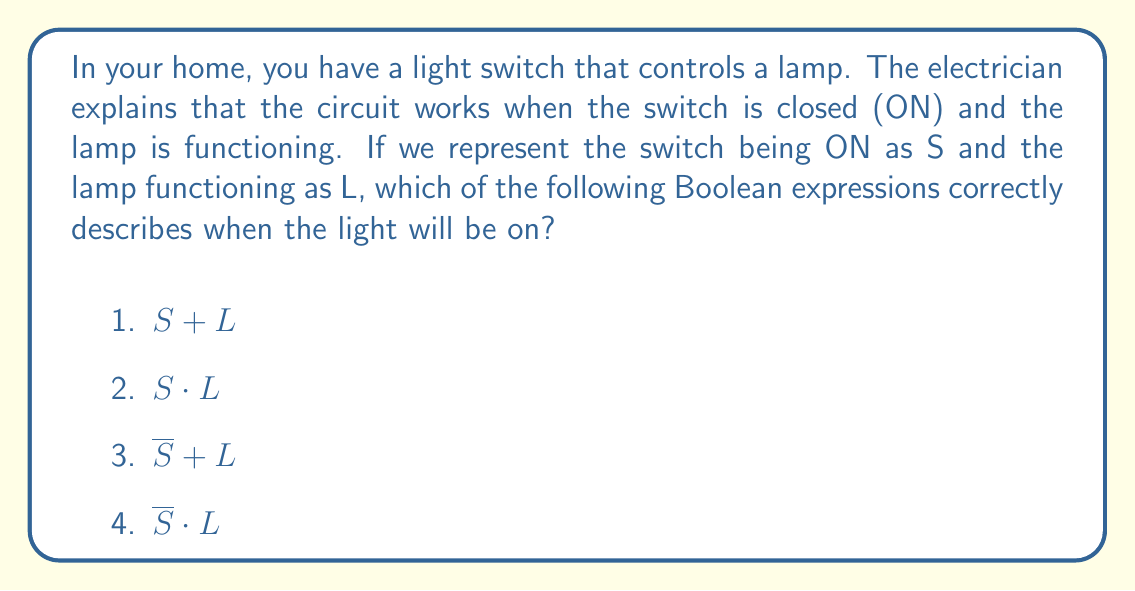Solve this math problem. Let's break this down step-by-step:

1) First, we need to understand what the symbols mean:
   - $S$ represents the switch being ON
   - $L$ represents the lamp functioning
   - The dot $\cdot$ means AND in Boolean logic
   - The plus $+$ means OR in Boolean logic
   - The bar over a letter (like $\overline{S}$) means NOT

2) Now, let's think about when the light will be on:
   - The switch must be ON (S)
   - AND
   - The lamp must be functioning (L)

3) In Boolean logic, when we need both conditions to be true, we use the AND operation, which is represented by the dot $\cdot$

4) Therefore, the correct expression is $S \cdot L$

5) Let's quickly check why the other options are incorrect:
   - $S + L$ would mean the light is on if either the switch is on OR the lamp is functioning, which isn't correct
   - $\overline{S} + L$ would mean the light is on if the switch is OFF or the lamp is functioning, which doesn't make sense
   - $\overline{S} \cdot L$ would mean the light is on if the switch is OFF and the lamp is functioning, which is impossible
Answer: $S \cdot L$ 